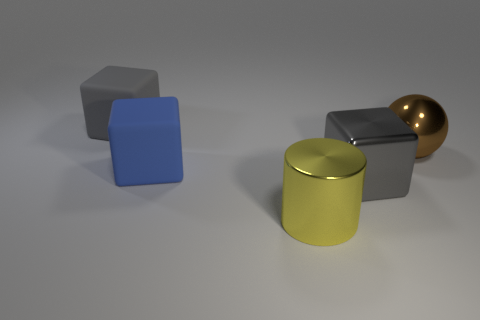Subtract all big rubber blocks. How many blocks are left? 1 Subtract all blue blocks. How many blocks are left? 2 Add 4 brown objects. How many objects exist? 9 Subtract 1 cylinders. How many cylinders are left? 0 Subtract all cubes. How many objects are left? 2 Subtract all red cubes. How many gray cylinders are left? 0 Add 2 big blue metal spheres. How many big blue metal spheres exist? 2 Subtract 0 cyan cylinders. How many objects are left? 5 Subtract all red blocks. Subtract all gray spheres. How many blocks are left? 3 Subtract all large gray balls. Subtract all brown balls. How many objects are left? 4 